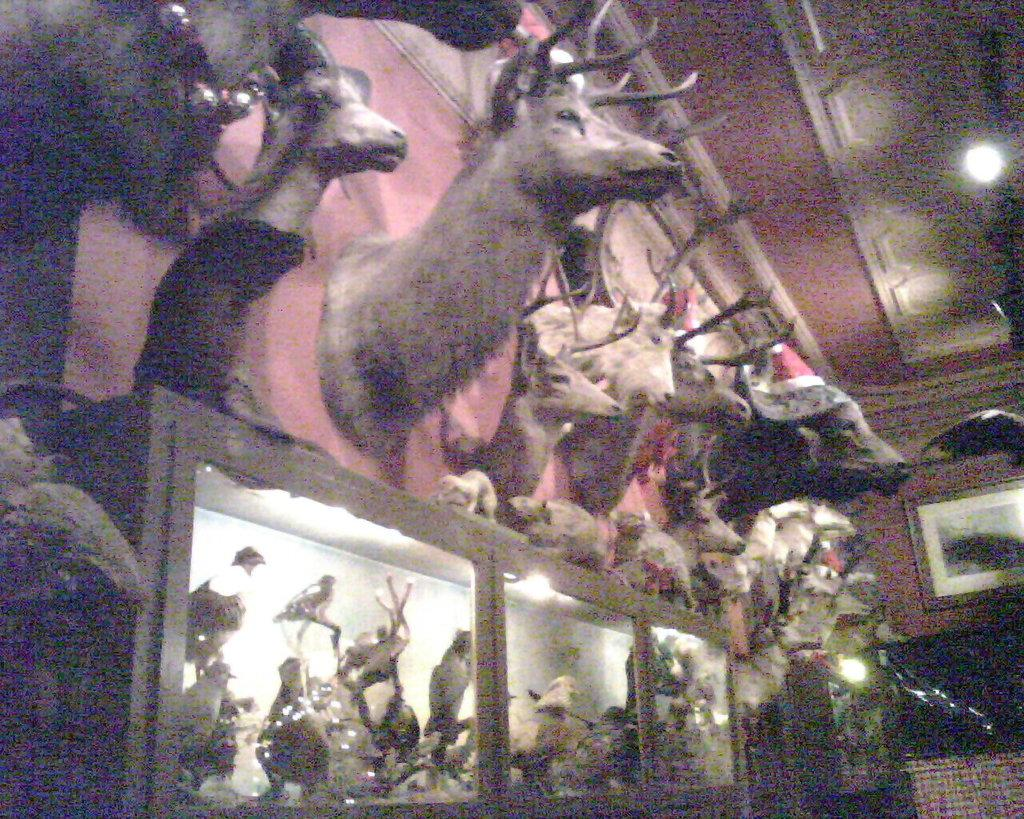What type of sculptures can be seen in the image? There are sculptures of animals and birds in the image. Are there any other elements in the image besides the sculptures? Yes, there are lights in the image. What can be seen on the wall in the background of the image? There is a frame on the wall in the background of the image. Where are the pets located in the image? There are no pets present in the image; it features sculptures of animals and birds. What type of blade can be seen in the image? There is no blade present in the image. 